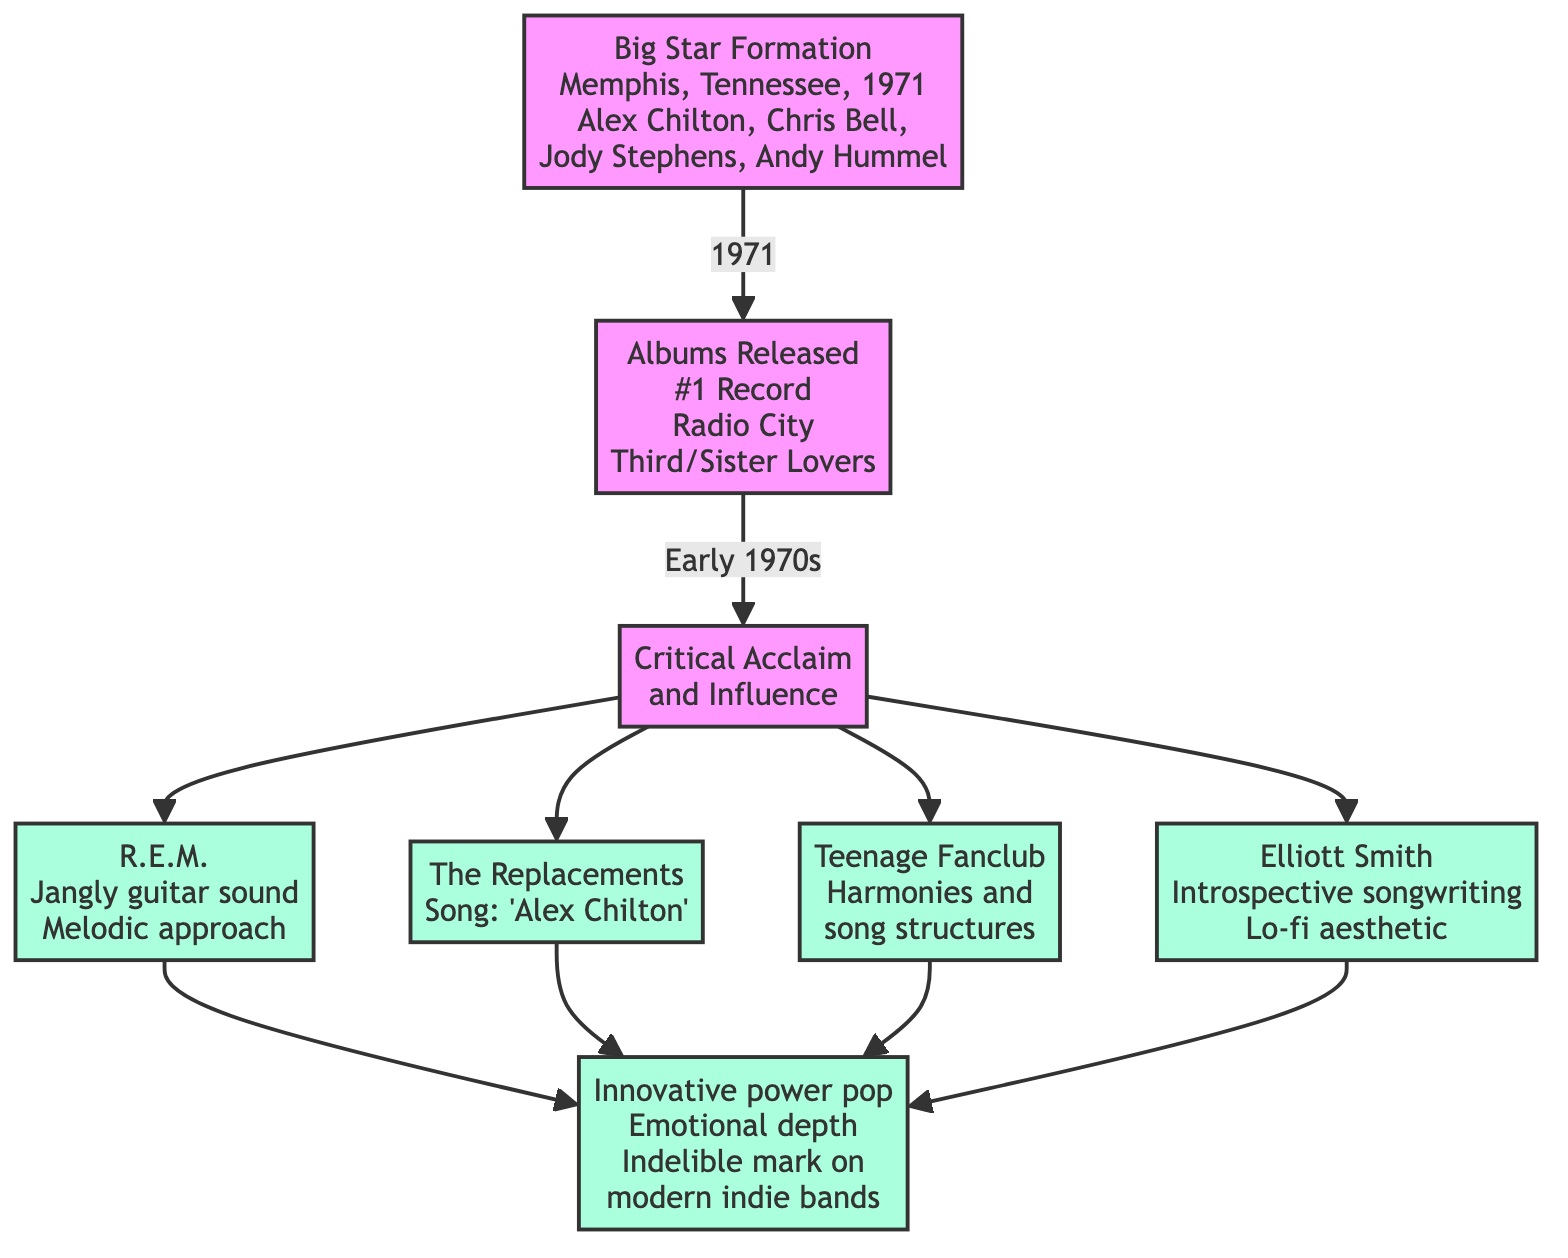What year was Big Star formed? The diagram states that Big Star was formed in 1971. This information is shown directly in the node labeled “Big Star Formation.”
Answer: 1971 How many albums did Big Star release in the early 1970s? According to the node labeled “Albums Released,” Big Star released three albums: '#1 Record', 'Radio City', and 'Third/Sister Lovers'. Therefore, the total is three.
Answer: 3 Which band is associated with a jangly guitar sound and melodic approach? The node labeled “R.E.M.” describes their sound as jangly guitar and melodic, directly linking them to this aspect of Big Star's influence.
Answer: R.E.M What tribute did The Replacements pay to Big Star? The node for “The Replacements” indicates they paid tribute by releasing a song titled "Alex Chilton," which reveals the connection and homage to Big Star.
Answer: "Alex Chilton" Which band’s music mirrors Big Star’s harmonies and song structures? The “Teenage Fanclub” node explicitly states that their music is compared to Big Star’s, particularly in terms of harmonies and song structures.
Answer: Teenage Fanclub How does Elliott Smith's aesthetic relate to Big Star? The node for “Elliott Smith” mentions that his lo-fi aesthetic and introspective songwriting were influenced by Big Star, demonstrating a direct influence connection.
Answer: Lo-fi aesthetic What is the overall impact of Big Star on modern indie bands? The conclusion node emphasizes that Big Star's innovative approach to power pop and emotional depth has left an indelible mark on modern indie bands, summarizing the result of their influence.
Answer: Indelible mark Which four bands are specifically mentioned as being influenced by Big Star? The diagram identifies four bands: R.E.M., The Replacements, Teenage Fanclub, and Elliott Smith, indicating their influence from Big Star. The information can be gathered by following edges from the “Critical Acclaim and Influence” node.
Answer: R.E.M., The Replacements, Teenage Fanclub, Elliott Smith What is the significance of Big Star's albums released in the early 1970s? The node labeled “Critical Acclaim and Influence” indicates that, despite limited commercial success, those albums received critical acclaim and had a significant influence within the music industry, marking their importance.
Answer: Critical acclaim and influence 